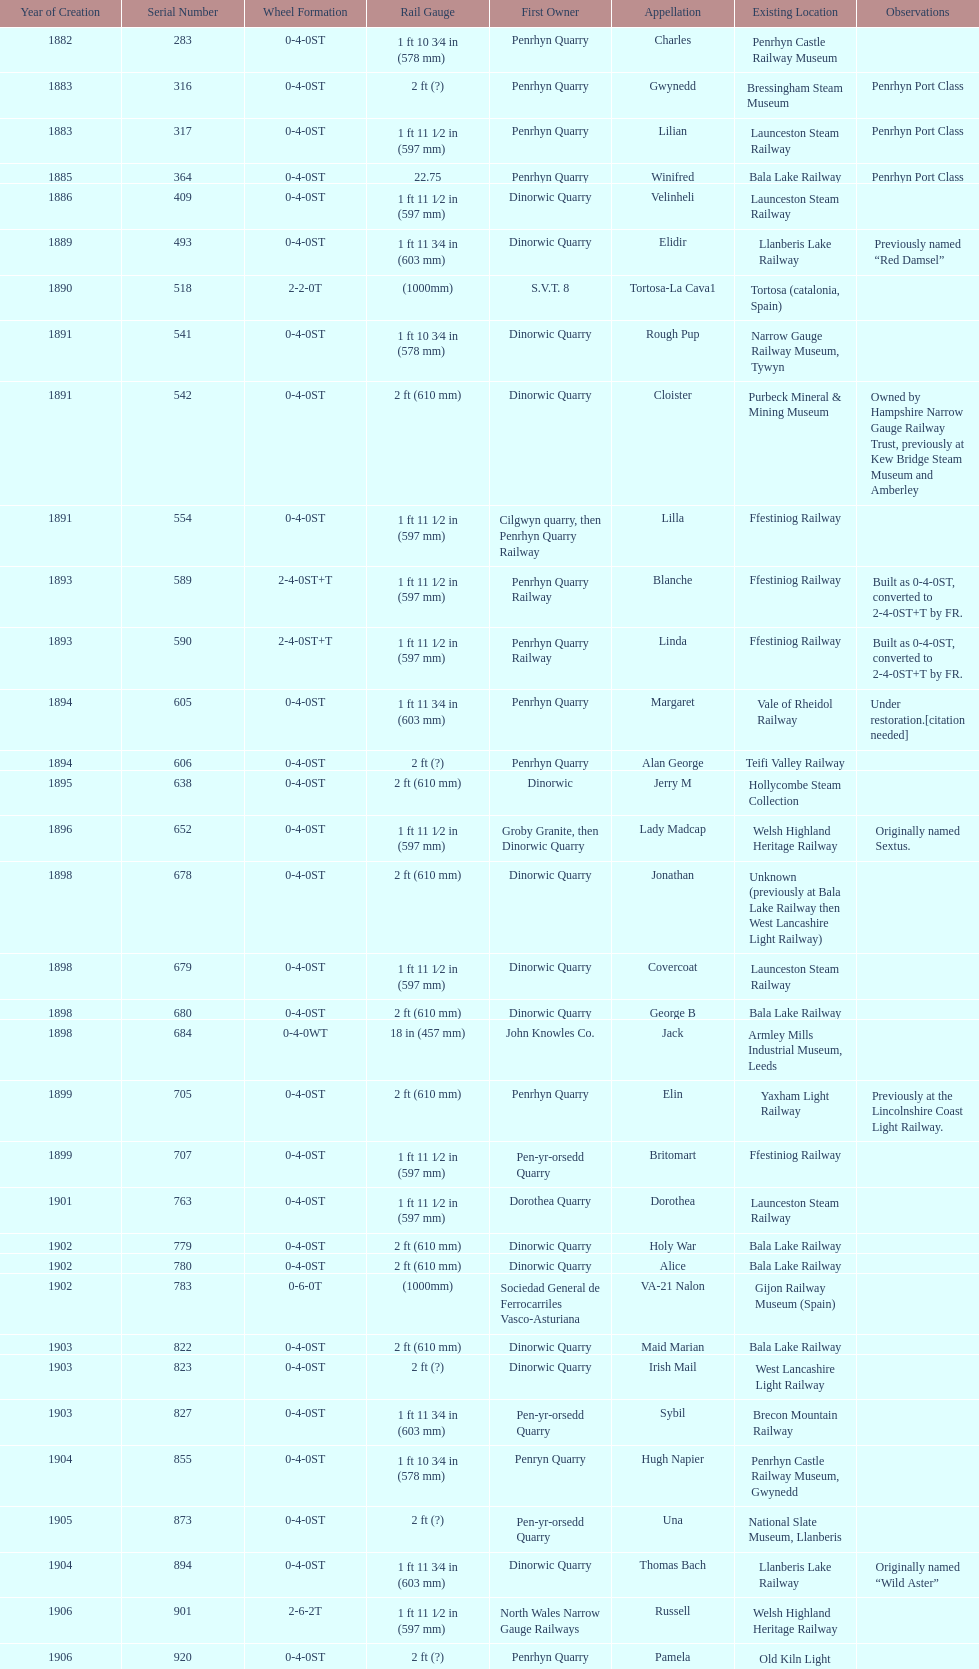Which works number had a larger gauge, 283 or 317? 317. 